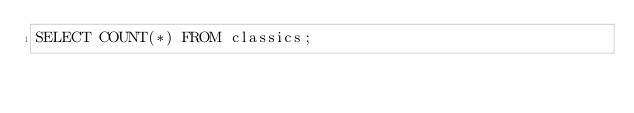<code> <loc_0><loc_0><loc_500><loc_500><_SQL_>SELECT COUNT(*) FROM classics;
</code> 